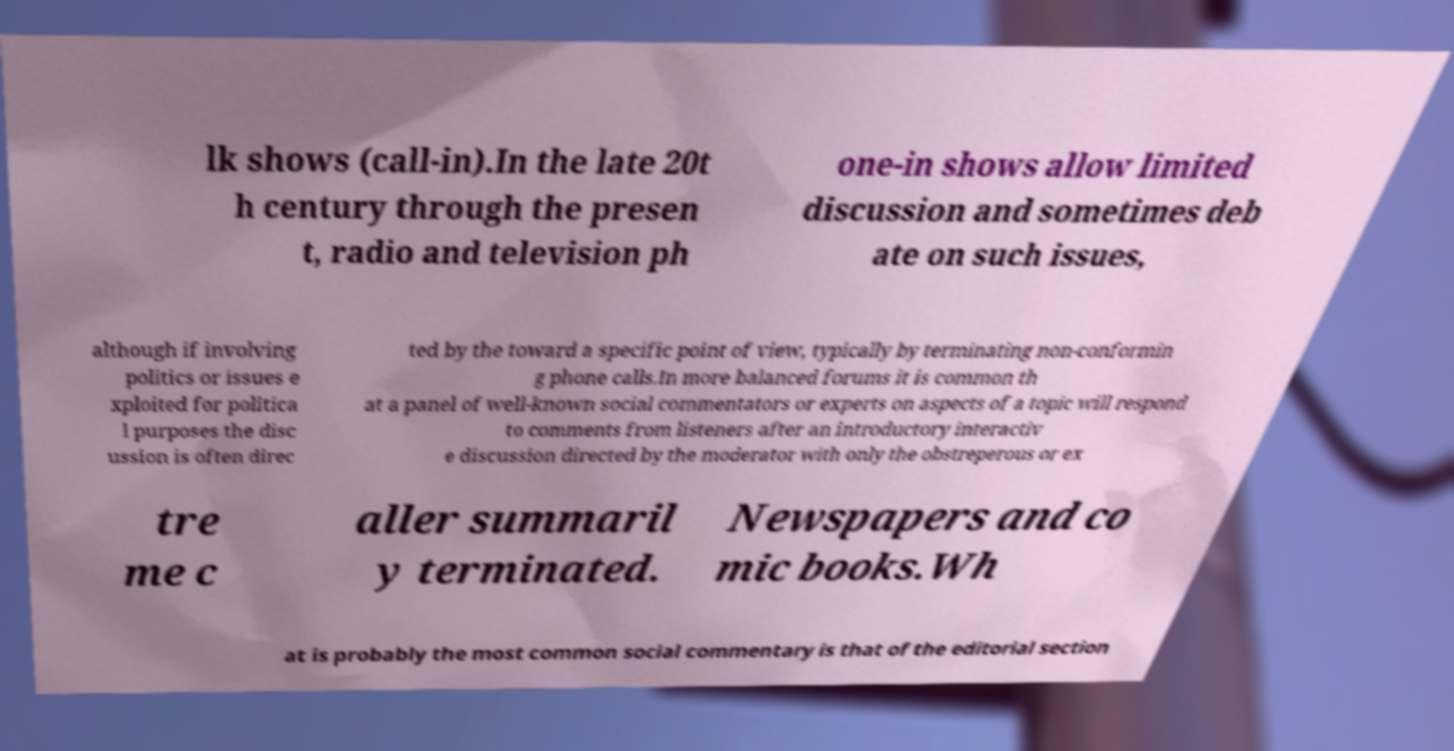There's text embedded in this image that I need extracted. Can you transcribe it verbatim? lk shows (call-in).In the late 20t h century through the presen t, radio and television ph one-in shows allow limited discussion and sometimes deb ate on such issues, although if involving politics or issues e xploited for politica l purposes the disc ussion is often direc ted by the toward a specific point of view, typically by terminating non-conformin g phone calls.In more balanced forums it is common th at a panel of well-known social commentators or experts on aspects of a topic will respond to comments from listeners after an introductory interactiv e discussion directed by the moderator with only the obstreperous or ex tre me c aller summaril y terminated. Newspapers and co mic books.Wh at is probably the most common social commentary is that of the editorial section 